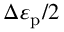Convert formula to latex. <formula><loc_0><loc_0><loc_500><loc_500>\Delta \varepsilon _ { p } / 2</formula> 